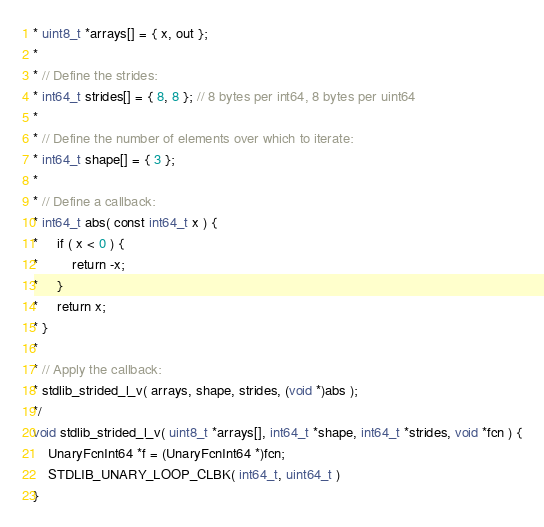<code> <loc_0><loc_0><loc_500><loc_500><_C_>* uint8_t *arrays[] = { x, out };
*
* // Define the strides:
* int64_t strides[] = { 8, 8 }; // 8 bytes per int64, 8 bytes per uint64
*
* // Define the number of elements over which to iterate:
* int64_t shape[] = { 3 };
*
* // Define a callback:
* int64_t abs( const int64_t x ) {
*     if ( x < 0 ) {
*         return -x;
*     }
*     return x;
* }
*
* // Apply the callback:
* stdlib_strided_l_v( arrays, shape, strides, (void *)abs );
*/
void stdlib_strided_l_v( uint8_t *arrays[], int64_t *shape, int64_t *strides, void *fcn ) {
	UnaryFcnInt64 *f = (UnaryFcnInt64 *)fcn;
	STDLIB_UNARY_LOOP_CLBK( int64_t, uint64_t )
}
</code> 